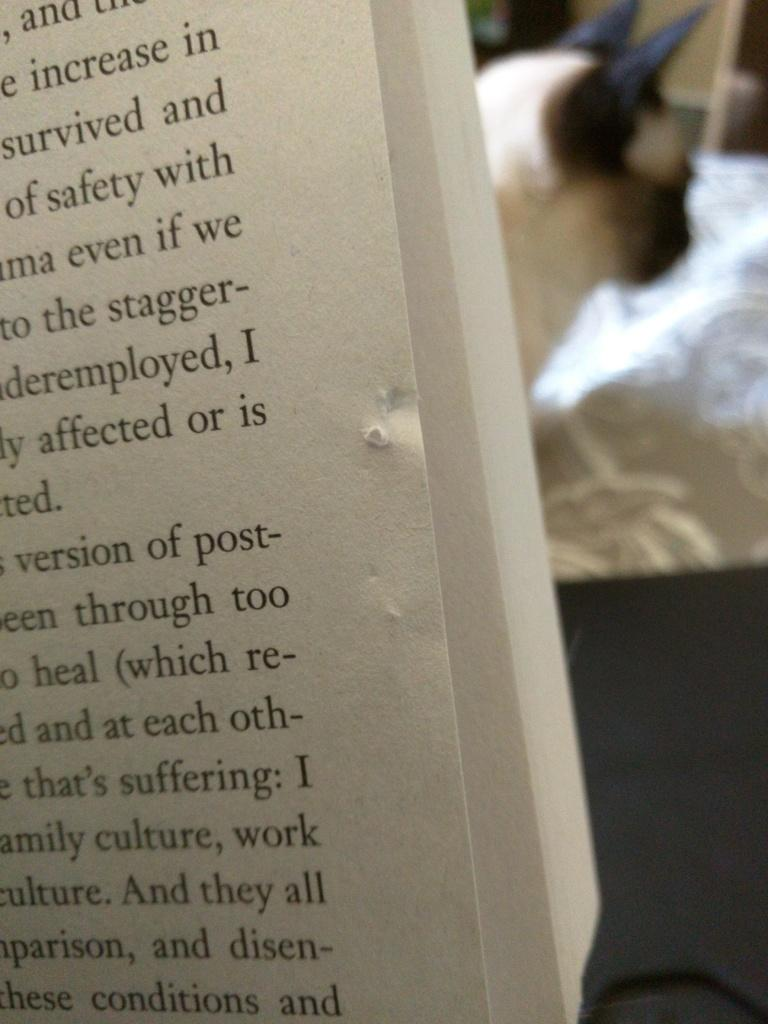What is the main object in the image that contains text? There is a book with text in the image. What animal can be seen on a bed in the image? There is a dog on a bed in the image. What can be seen in the background of the image? There is a wall in the background of the image. How many clocks are visible on the wall in the image? There are no clocks visible on the wall in the image. What type of knot is the dog using to secure the bed in the image? There is no knot present in the image, and the dog is not securing the bed. 